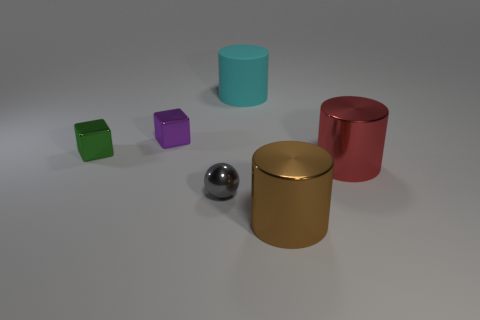Add 1 red rubber cylinders. How many objects exist? 7 Subtract all spheres. How many objects are left? 5 Subtract all red shiny objects. Subtract all brown things. How many objects are left? 4 Add 2 big cyan matte cylinders. How many big cyan matte cylinders are left? 3 Add 6 big cylinders. How many big cylinders exist? 9 Subtract 0 brown cubes. How many objects are left? 6 